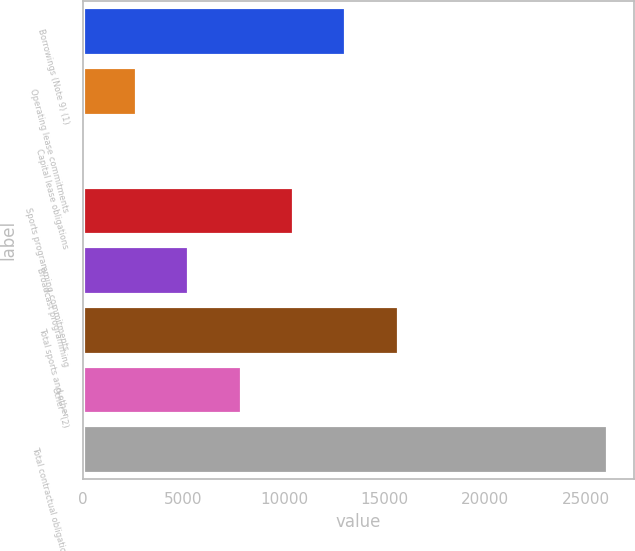Convert chart to OTSL. <chart><loc_0><loc_0><loc_500><loc_500><bar_chart><fcel>Borrowings (Note 9) (1)<fcel>Operating lease commitments<fcel>Capital lease obligations<fcel>Sports programming commitments<fcel>Broadcast programming<fcel>Total sports and other<fcel>Other^(2)<fcel>Total contractual obligations<nl><fcel>13052.5<fcel>2625.7<fcel>19<fcel>10445.8<fcel>5232.4<fcel>15659.2<fcel>7839.1<fcel>26086<nl></chart> 